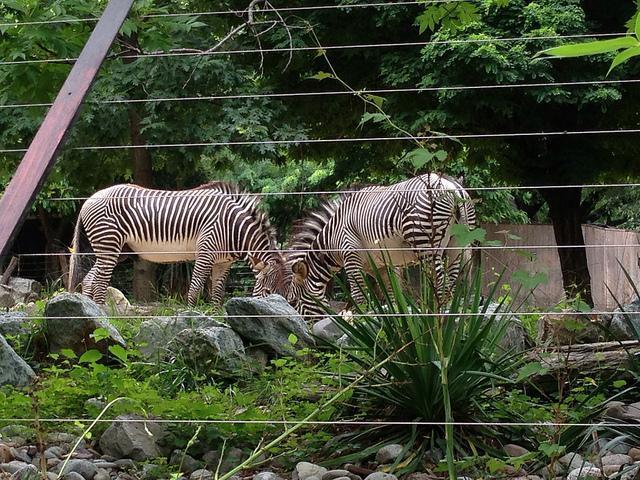How many zebras are in the photo?
Give a very brief answer. 2. How many pizzas are here?
Give a very brief answer. 0. 